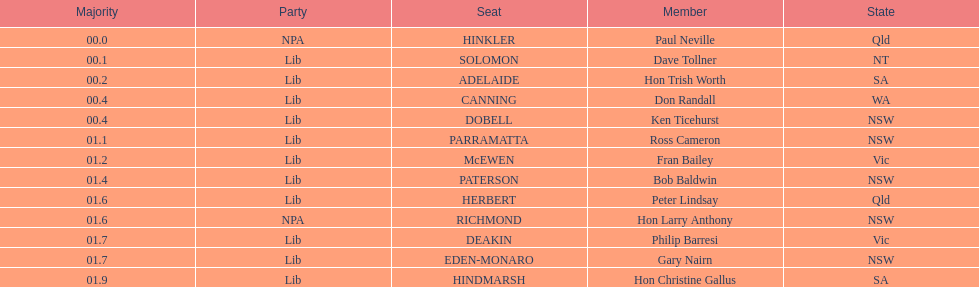How many states were represented in the seats? 6. 